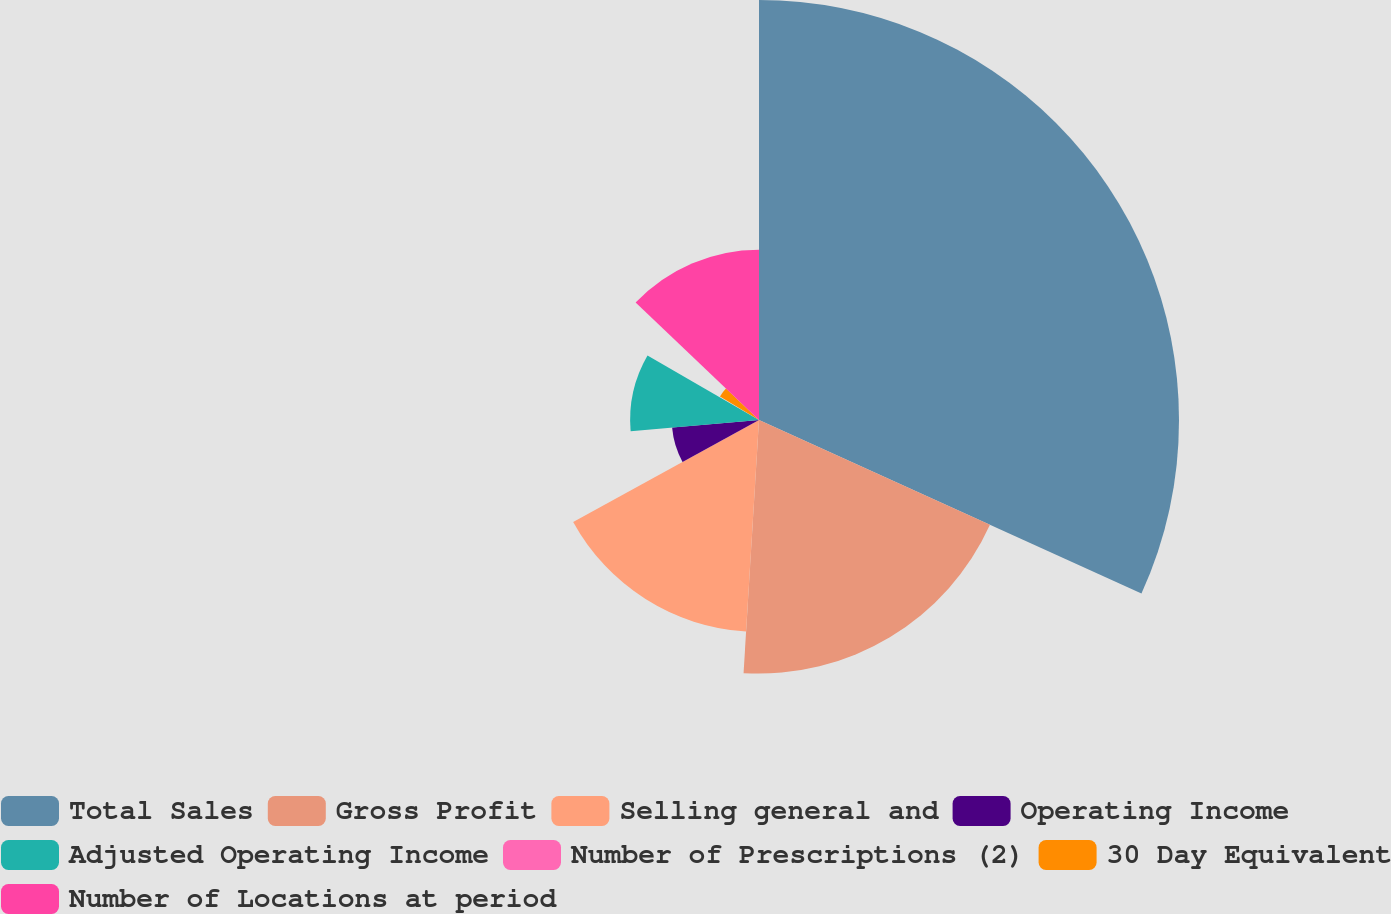<chart> <loc_0><loc_0><loc_500><loc_500><pie_chart><fcel>Total Sales<fcel>Gross Profit<fcel>Selling general and<fcel>Operating Income<fcel>Adjusted Operating Income<fcel>Number of Prescriptions (2)<fcel>30 Day Equivalent<fcel>Number of Locations at period<nl><fcel>31.78%<fcel>19.19%<fcel>16.04%<fcel>6.6%<fcel>9.75%<fcel>0.3%<fcel>3.45%<fcel>12.89%<nl></chart> 